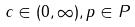Convert formula to latex. <formula><loc_0><loc_0><loc_500><loc_500>c \in ( 0 , \infty ) , p \in P</formula> 